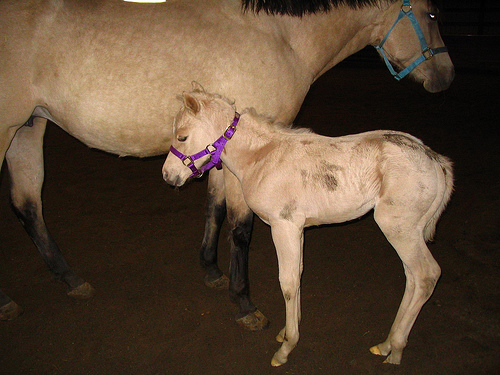<image>
Can you confirm if the halter is on the horse? No. The halter is not positioned on the horse. They may be near each other, but the halter is not supported by or resting on top of the horse. Is the small horse behind the horse? No. The small horse is not behind the horse. From this viewpoint, the small horse appears to be positioned elsewhere in the scene. Is there a foal behind the horse? No. The foal is not behind the horse. From this viewpoint, the foal appears to be positioned elsewhere in the scene. Where is the pony in relation to the horse? Is it next to the horse? Yes. The pony is positioned adjacent to the horse, located nearby in the same general area. 